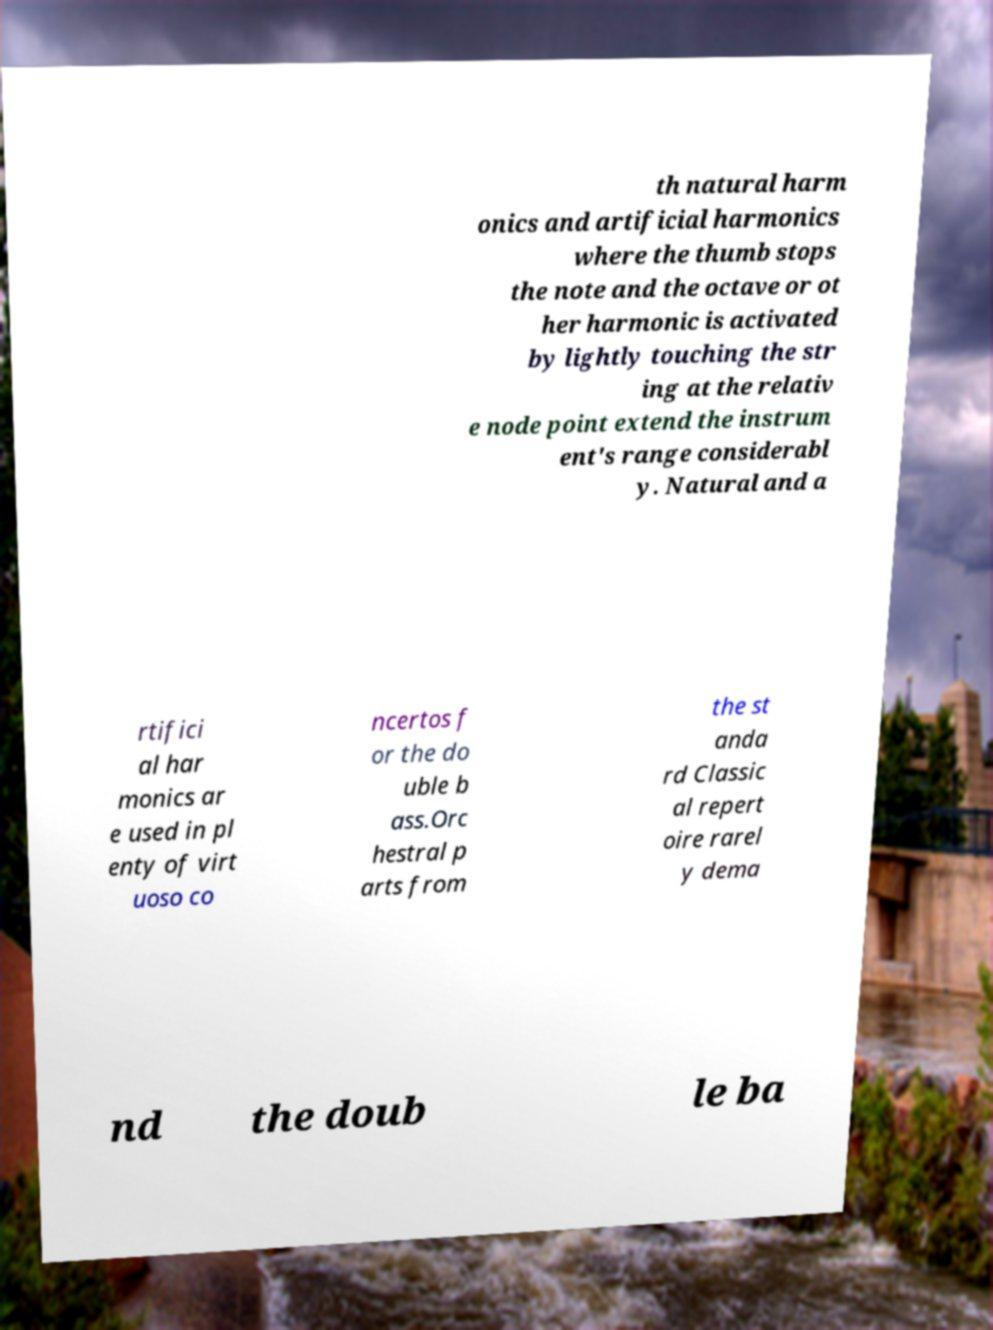Please identify and transcribe the text found in this image. th natural harm onics and artificial harmonics where the thumb stops the note and the octave or ot her harmonic is activated by lightly touching the str ing at the relativ e node point extend the instrum ent's range considerabl y. Natural and a rtifici al har monics ar e used in pl enty of virt uoso co ncertos f or the do uble b ass.Orc hestral p arts from the st anda rd Classic al repert oire rarel y dema nd the doub le ba 